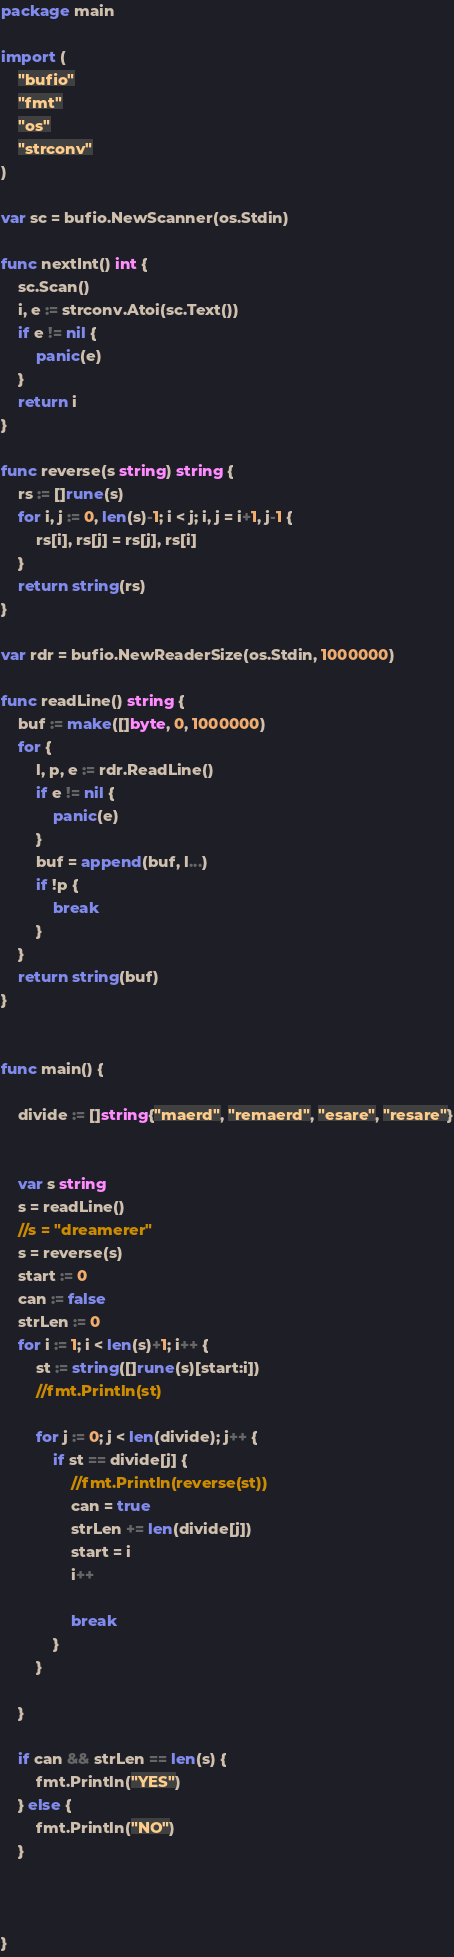<code> <loc_0><loc_0><loc_500><loc_500><_Go_>package main

import (
	"bufio"
	"fmt"
	"os"
	"strconv"
)

var sc = bufio.NewScanner(os.Stdin)

func nextInt() int {
	sc.Scan()
	i, e := strconv.Atoi(sc.Text())
	if e != nil {
		panic(e)
	}
	return i
}

func reverse(s string) string {
	rs := []rune(s)
	for i, j := 0, len(s)-1; i < j; i, j = i+1, j-1 {
		rs[i], rs[j] = rs[j], rs[i]
	}
	return string(rs)
}

var rdr = bufio.NewReaderSize(os.Stdin, 1000000)

func readLine() string {
	buf := make([]byte, 0, 1000000)
	for {
		l, p, e := rdr.ReadLine()
		if e != nil {
			panic(e)
		}
		buf = append(buf, l...)
		if !p {
			break
		}
	}
	return string(buf)
}


func main() {
		
	divide := []string{"maerd", "remaerd", "esare", "resare"}
	

	var s string
	s = readLine()
	//s = "dreamerer"
	s = reverse(s)
	start := 0
	can := false
	strLen := 0
	for i := 1; i < len(s)+1; i++ {
		st := string([]rune(s)[start:i])
		//fmt.Println(st)
	
		for j := 0; j < len(divide); j++ {
			if st == divide[j] {
				//fmt.Println(reverse(st))
				can = true
				strLen += len(divide[j])
				start = i
				i++
				
				break
			}
		}
		
	}
	
	if can && strLen == len(s) {
		fmt.Println("YES")
	} else {
		fmt.Println("NO")
	}

	

}
</code> 